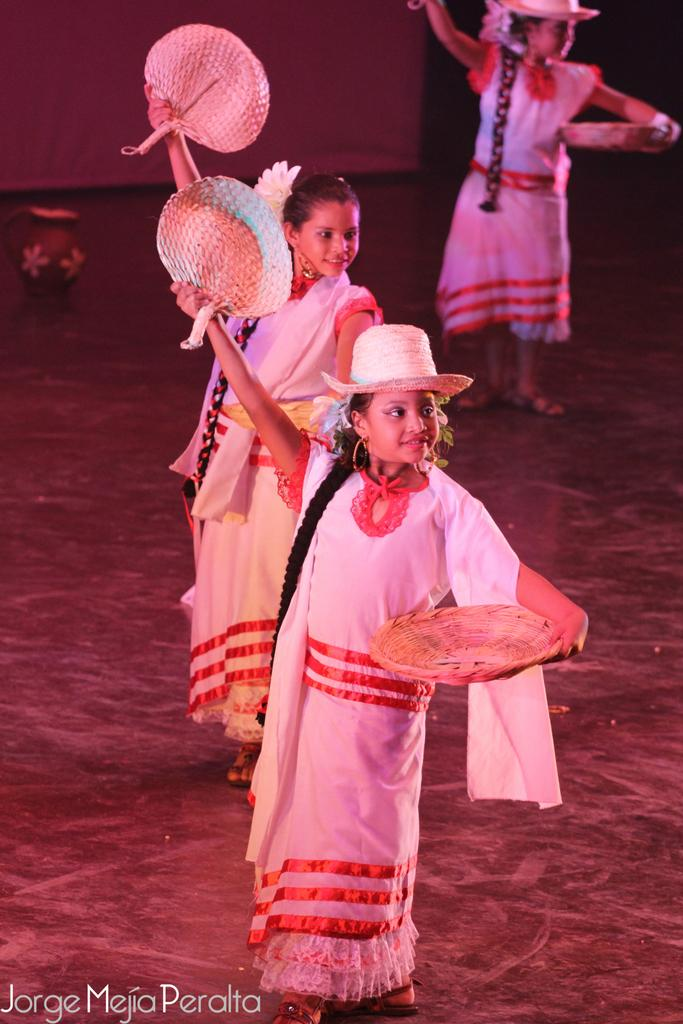How many girls are present in the image? There are three girls in the image. What are the girls holding in their hands? The girls are holding objects in the image. What activity are the girls engaged in? The girls are dancing on the floor in the image. What can be seen on the left side of the image? There is a pot on the left side of the image. Where is the fifth girl sitting during the meeting in the image? There is no fifth girl or meeting present in the image. What type of blow can be seen being delivered by one of the girls in the image? There is no blow being delivered by any of the girls in the image. 